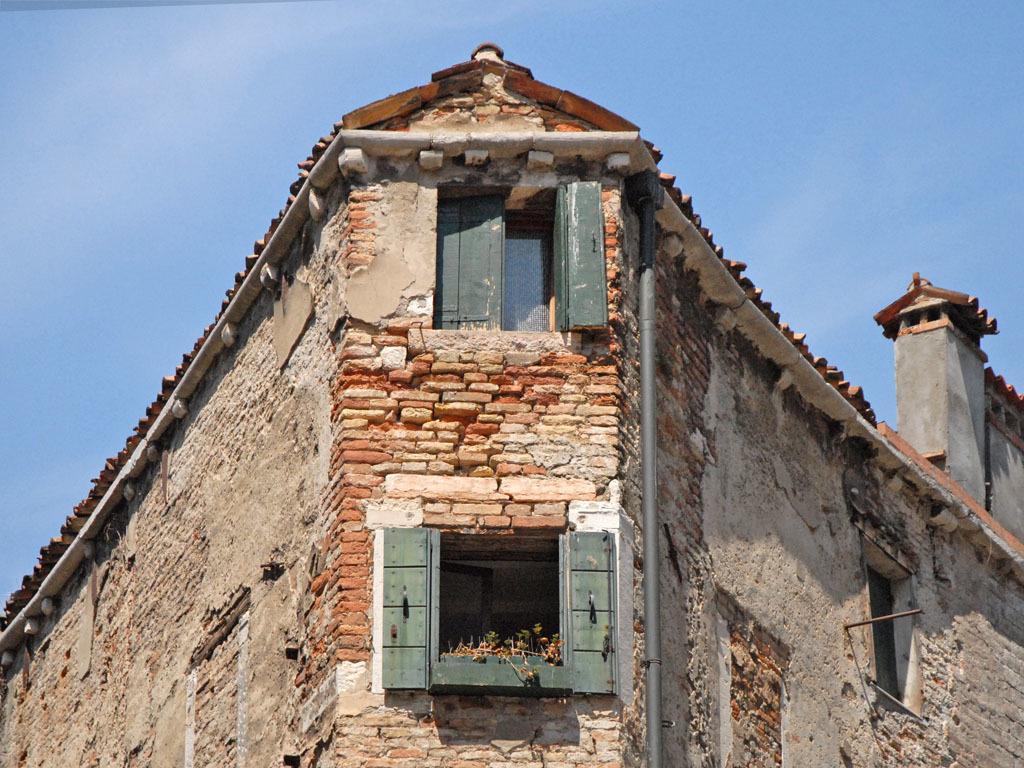How would you summarize this image in a sentence or two? In the picture I can see a building which has windows. In the background I can see the sky. 